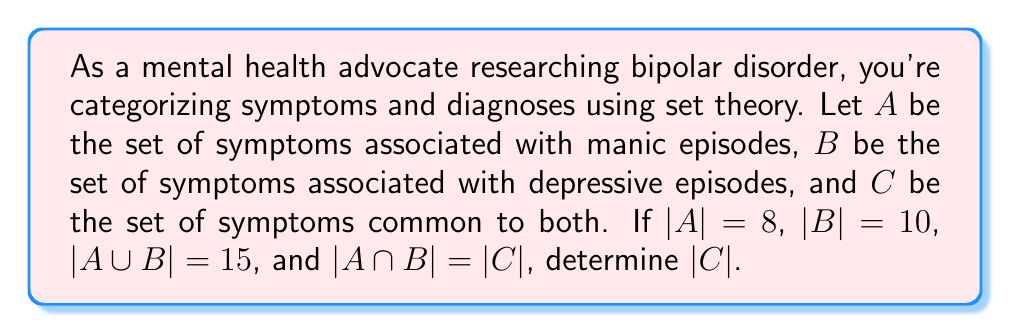Help me with this question. To solve this problem, we'll use the following steps:

1) Recall the formula for the number of elements in the union of two sets:
   $$|A \cup B| = |A| + |B| - |A \cap B|$$

2) We're given that $|A \cup B| = 15$, $|A| = 8$, and $|B| = 10$. Let's substitute these into the formula:
   $$15 = 8 + 10 - |A \cap B|$$

3) We're also told that $|A \cap B| = |C|$, so we can rewrite this as:
   $$15 = 8 + 10 - |C|$$

4) Now, let's solve for $|C|$:
   $$15 = 18 - |C|$$
   $$|C| = 18 - 15$$
   $$|C| = 3$$

Therefore, there are 3 symptoms common to both manic and depressive episodes in bipolar disorder.
Answer: $|C| = 3$ 